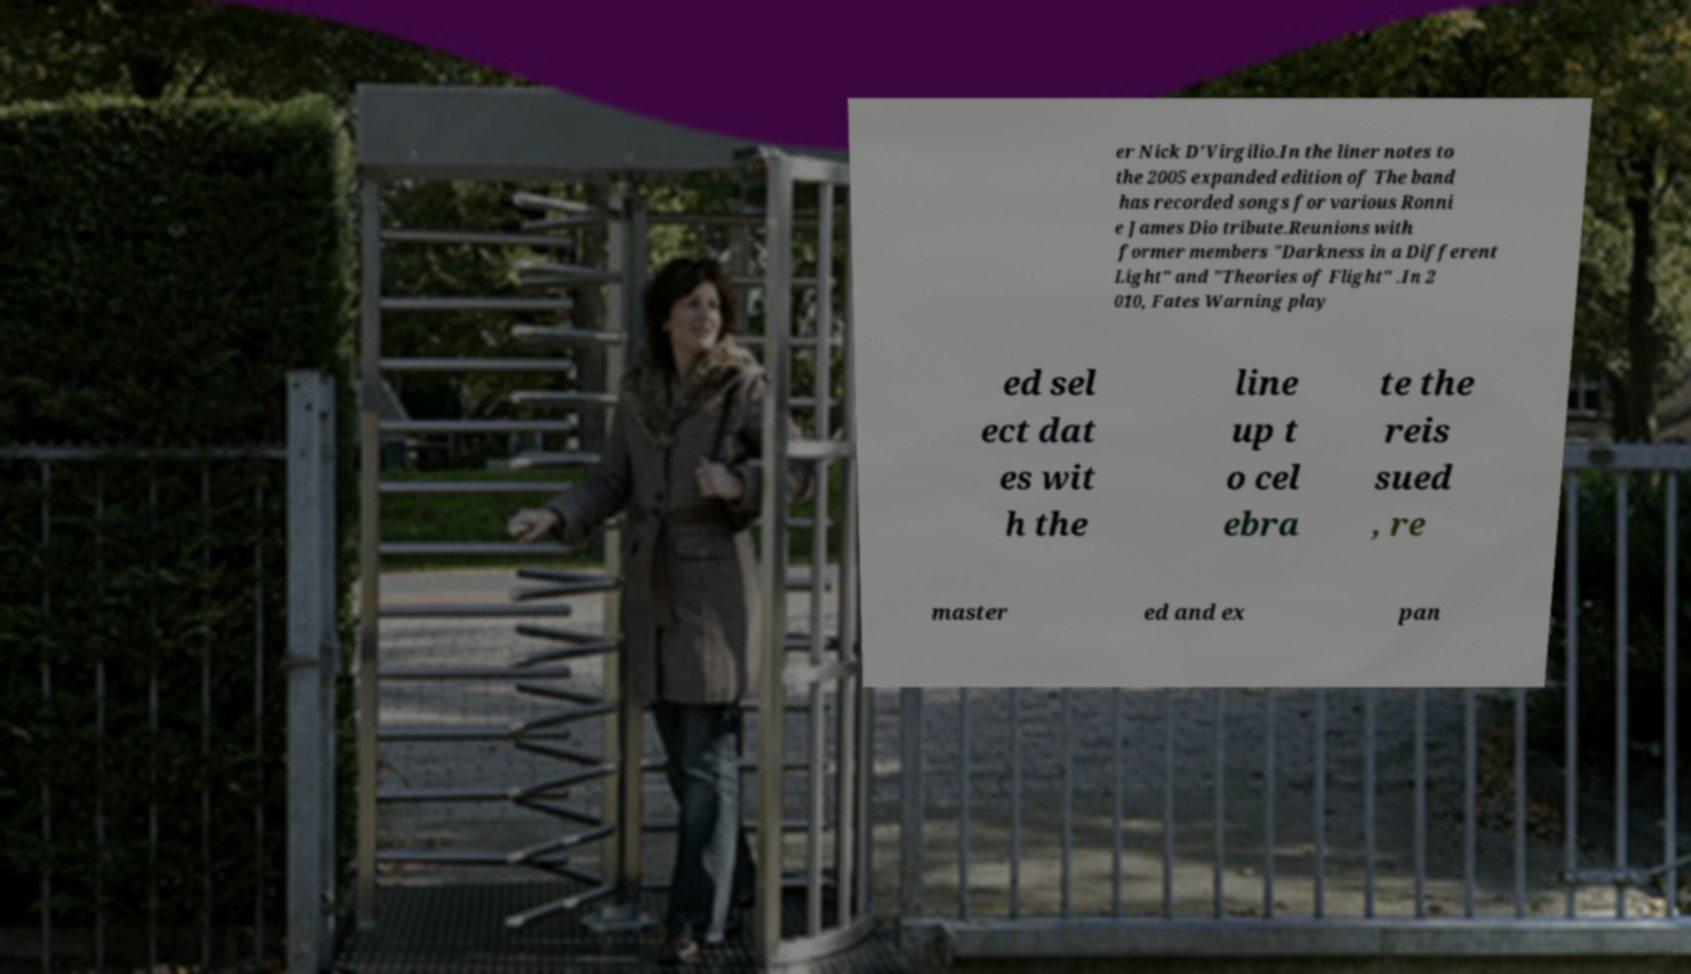Please identify and transcribe the text found in this image. er Nick D'Virgilio.In the liner notes to the 2005 expanded edition of The band has recorded songs for various Ronni e James Dio tribute.Reunions with former members "Darkness in a Different Light" and "Theories of Flight" .In 2 010, Fates Warning play ed sel ect dat es wit h the line up t o cel ebra te the reis sued , re master ed and ex pan 